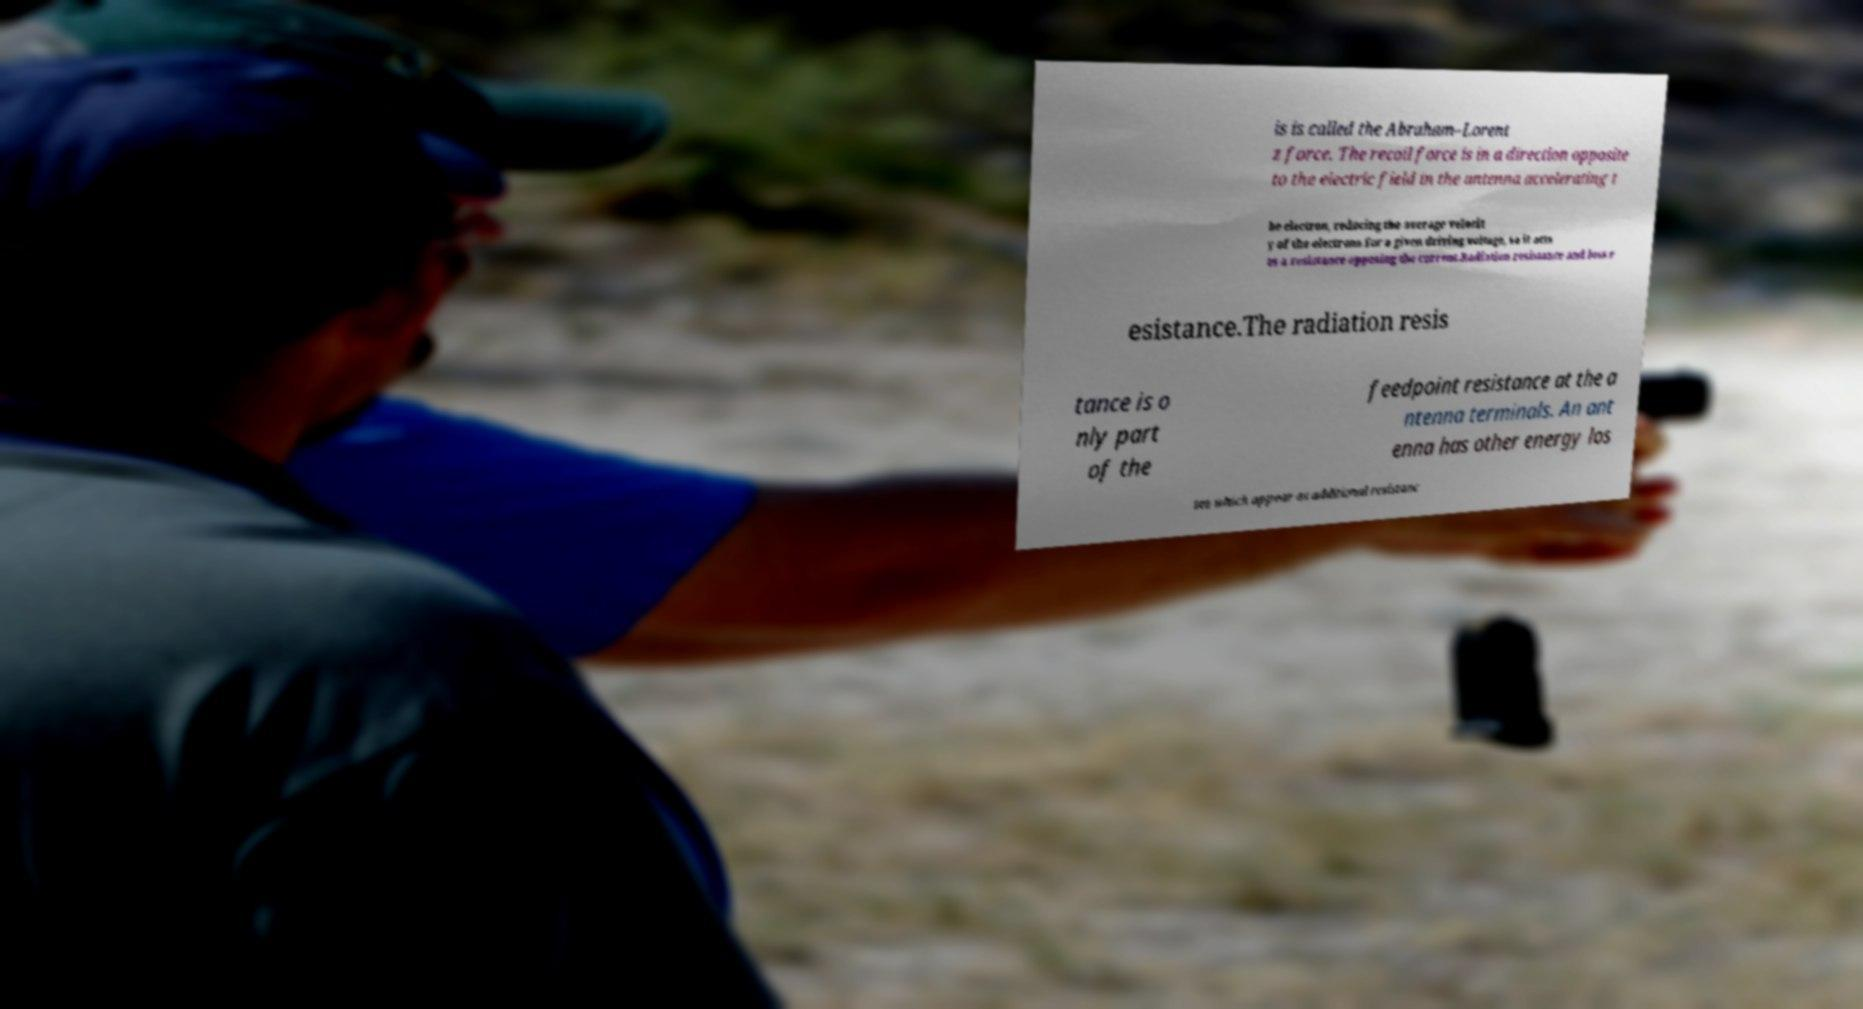Please identify and transcribe the text found in this image. is is called the Abraham–Lorent z force. The recoil force is in a direction opposite to the electric field in the antenna accelerating t he electron, reducing the average velocit y of the electrons for a given driving voltage, so it acts as a resistance opposing the current.Radiation resistance and loss r esistance.The radiation resis tance is o nly part of the feedpoint resistance at the a ntenna terminals. An ant enna has other energy los ses which appear as additional resistanc 